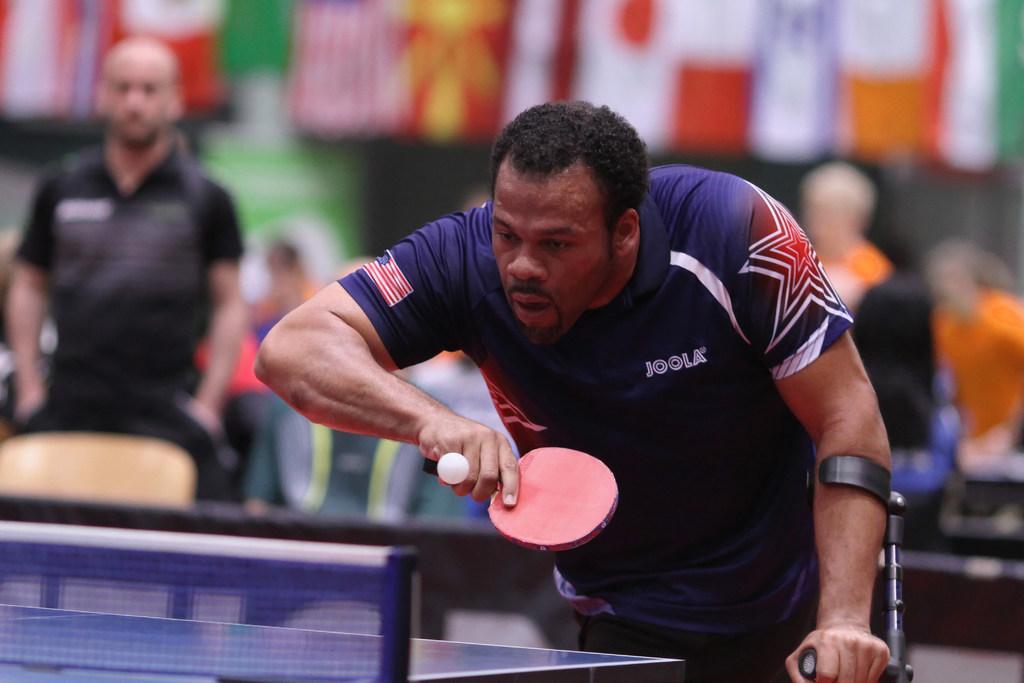Can you describe this image briefly? Here I can see a man wearing a t-shirt and playing table tennis. He is holding a walking stick in his left hand. On the left side there is another person standing. In the background, I can see some more people and flags. The background is blurred. 